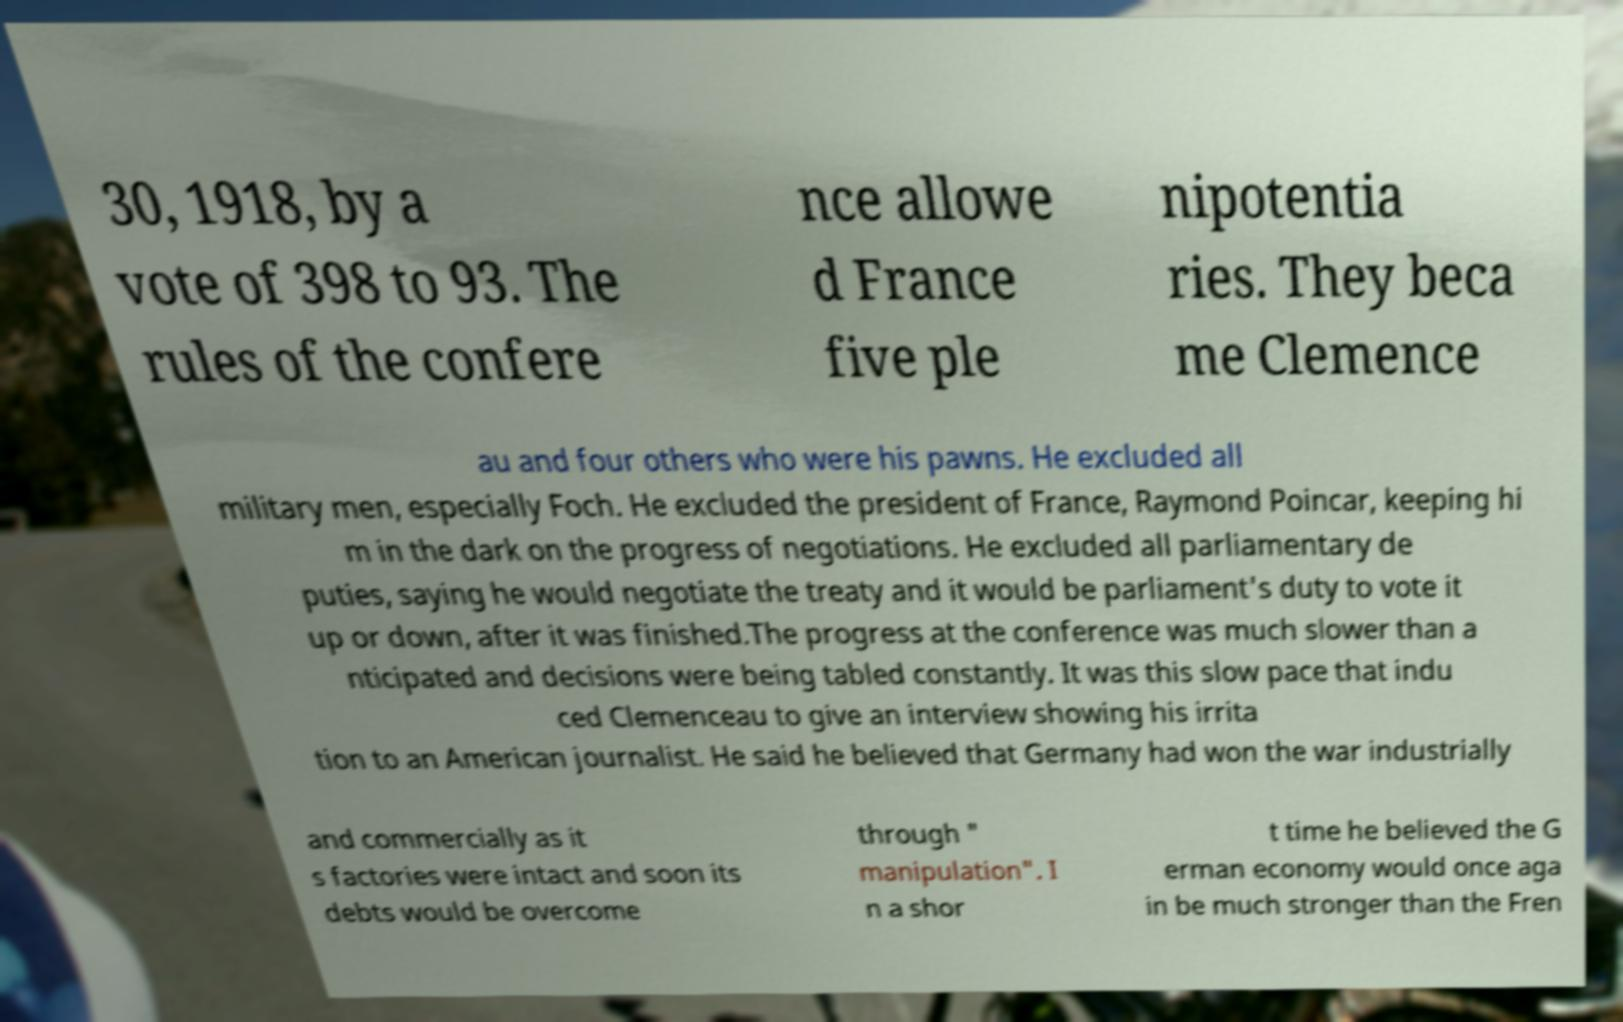I need the written content from this picture converted into text. Can you do that? 30, 1918, by a vote of 398 to 93. The rules of the confere nce allowe d France five ple nipotentia ries. They beca me Clemence au and four others who were his pawns. He excluded all military men, especially Foch. He excluded the president of France, Raymond Poincar, keeping hi m in the dark on the progress of negotiations. He excluded all parliamentary de puties, saying he would negotiate the treaty and it would be parliament's duty to vote it up or down, after it was finished.The progress at the conference was much slower than a nticipated and decisions were being tabled constantly. It was this slow pace that indu ced Clemenceau to give an interview showing his irrita tion to an American journalist. He said he believed that Germany had won the war industrially and commercially as it s factories were intact and soon its debts would be overcome through " manipulation". I n a shor t time he believed the G erman economy would once aga in be much stronger than the Fren 